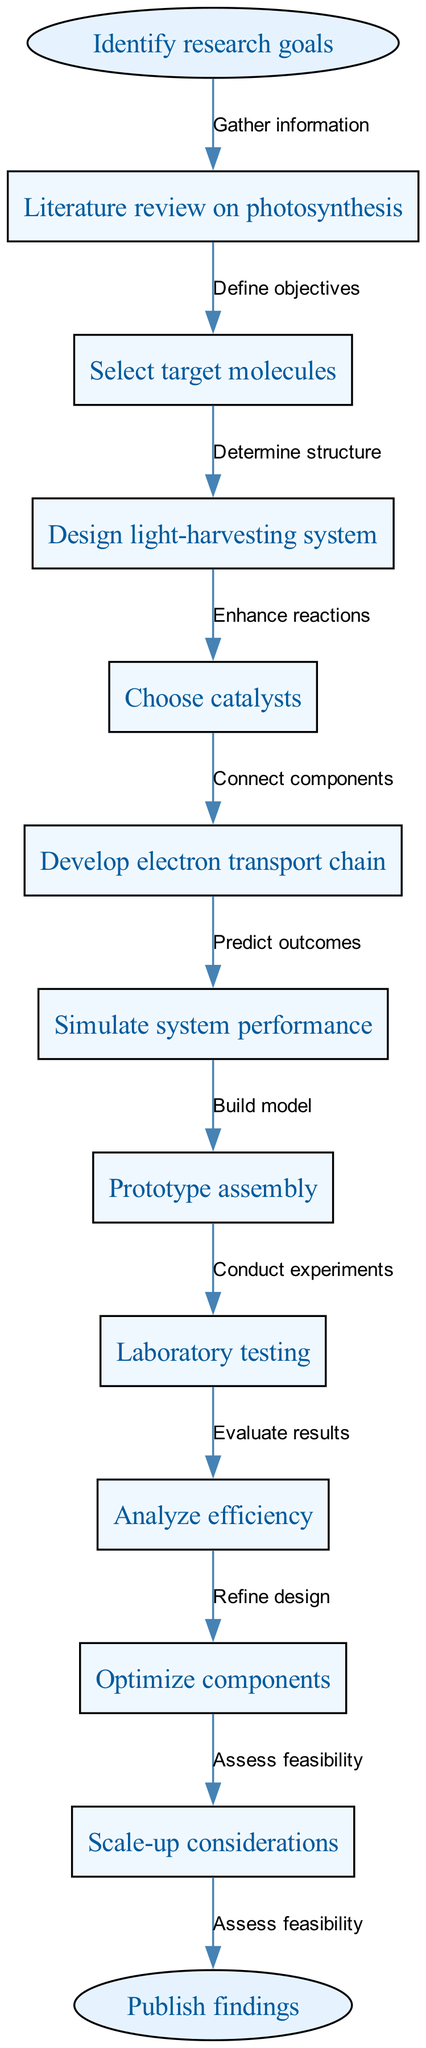What is the starting point of the flow chart? The flow chart starts with the node labeled "Identify research goals." This is the first point in the process, guiding the subsequent steps in designing a synthetic photosynthetic system.
Answer: Identify research goals How many nodes are present in the diagram? The diagram includes a total of 10 nodes, which represent different steps involved in the design and optimization of the synthetic photosynthetic system.
Answer: 10 What is the last step before publishing findings? The last step before "Publish findings" is "Assess feasibility," which evaluates the practical implications of the research outcomes, ensuring everything is ready for publication.
Answer: Assess feasibility Which step comes after "Develop electron transport chain"? After "Develop electron transport chain" the next step in the sequence is "Simulate system performance." This indicates that simulation occurs following the development of the electron transport chain.
Answer: Simulate system performance How many edges are there in total in the diagram? There are a total of 11 edges in the diagram, each illustrating the flow from one node to the next or the relationship between steps in the process.
Answer: 11 Which step requires laboratory testing? The step that requires laboratory testing is "Laboratory testing," which focuses on conducting practical experiments to determine the system's performance and efficiency.
Answer: Laboratory testing What connects "Select target molecules" and "Design light-harvesting system"? "Define objectives" connects "Select target molecules" and "Design light-harvesting system," indicating that objectives must be defined before proceeding to design a light-harvesting system.
Answer: Define objectives Which two steps enhance the reactions in the process? The two steps that enhance the reactions are "Choose catalysts" and "Optimize components." Choosing catalysts can improve reaction rates, while optimizing components refines overall efficiency.
Answer: Choose catalysts, Optimize components What is the primary focus of the "Analyze efficiency" step? The primary focus of "Analyze efficiency" is to evaluate the outcomes of the laboratory testing and simulations, determining how effective the synthetic photosynthetic system is.
Answer: Evaluate results 